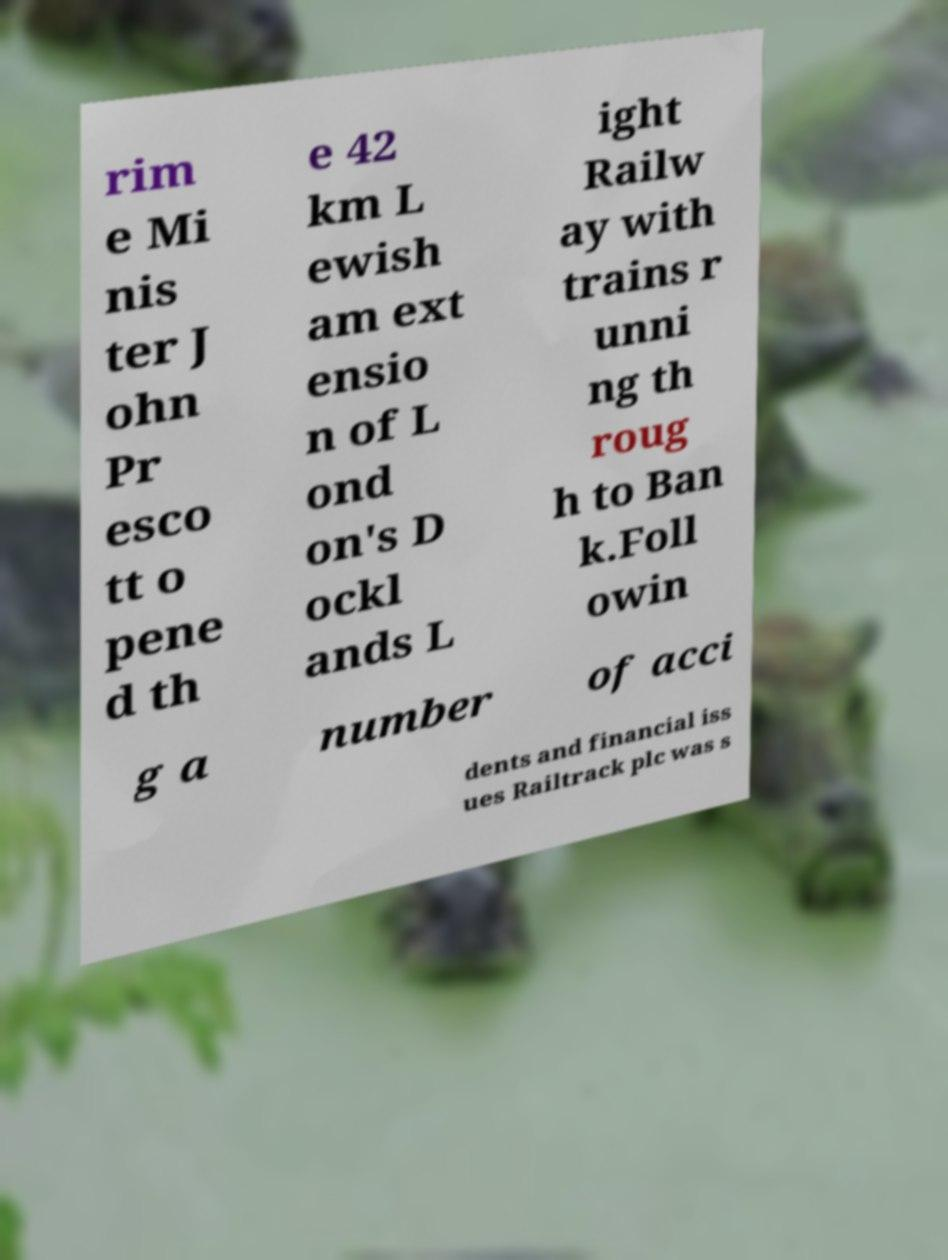Can you read and provide the text displayed in the image?This photo seems to have some interesting text. Can you extract and type it out for me? rim e Mi nis ter J ohn Pr esco tt o pene d th e 42 km L ewish am ext ensio n of L ond on's D ockl ands L ight Railw ay with trains r unni ng th roug h to Ban k.Foll owin g a number of acci dents and financial iss ues Railtrack plc was s 